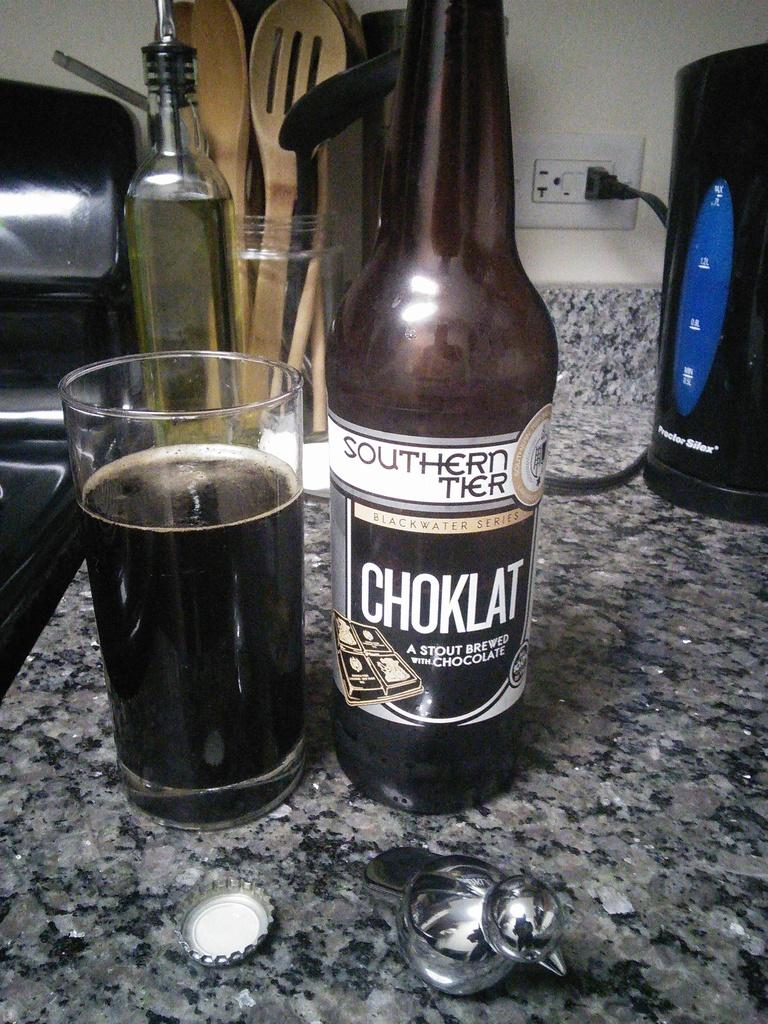What piece of furniture is present in the image? There is a table in the image. What is placed on the table? There is a wine glass and a bottle on the table. What type of electrical outlet is visible on the table? There is a socket on the table. What direction is the beam of light coming from in the image? There is no beam of light present in the image. What type of sport is being played in the image? There is no sport or volleyball depicted in the image. 